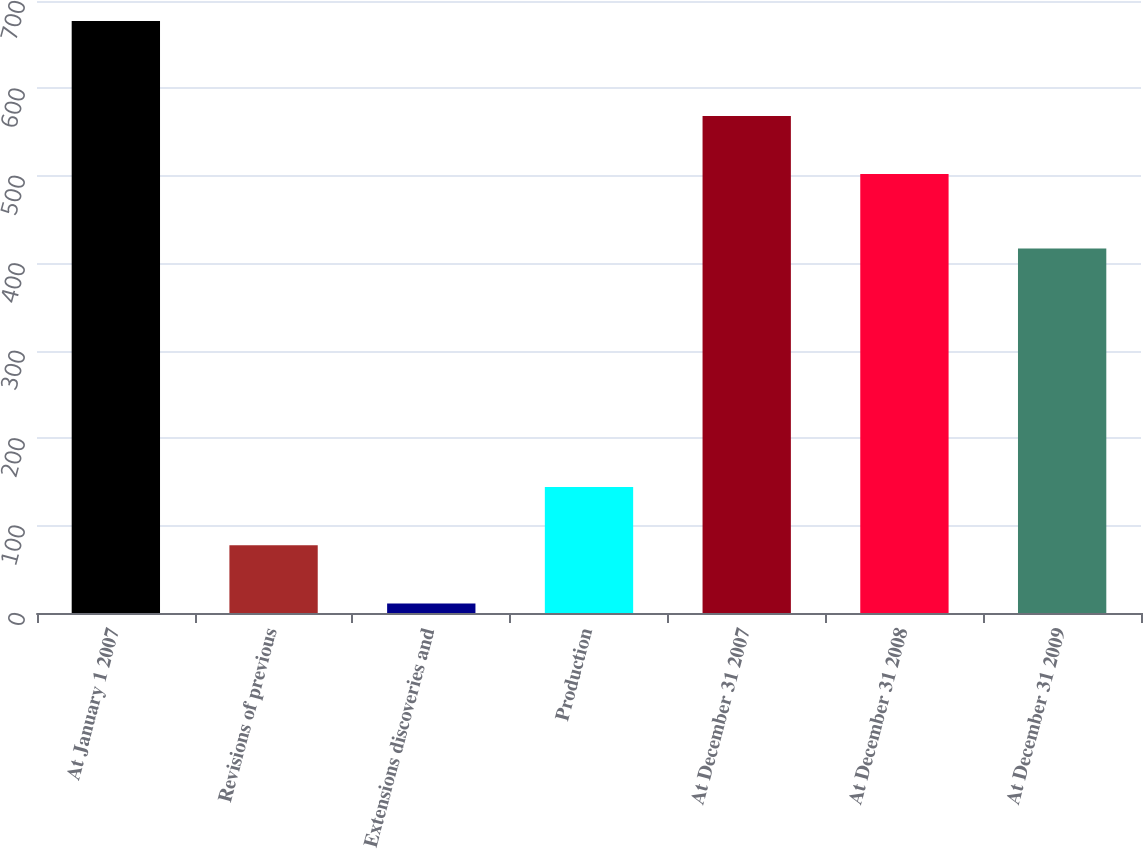Convert chart to OTSL. <chart><loc_0><loc_0><loc_500><loc_500><bar_chart><fcel>At January 1 2007<fcel>Revisions of previous<fcel>Extensions discoveries and<fcel>Production<fcel>At December 31 2007<fcel>At December 31 2008<fcel>At December 31 2009<nl><fcel>677<fcel>77.6<fcel>11<fcel>144.2<fcel>568.6<fcel>502<fcel>417<nl></chart> 